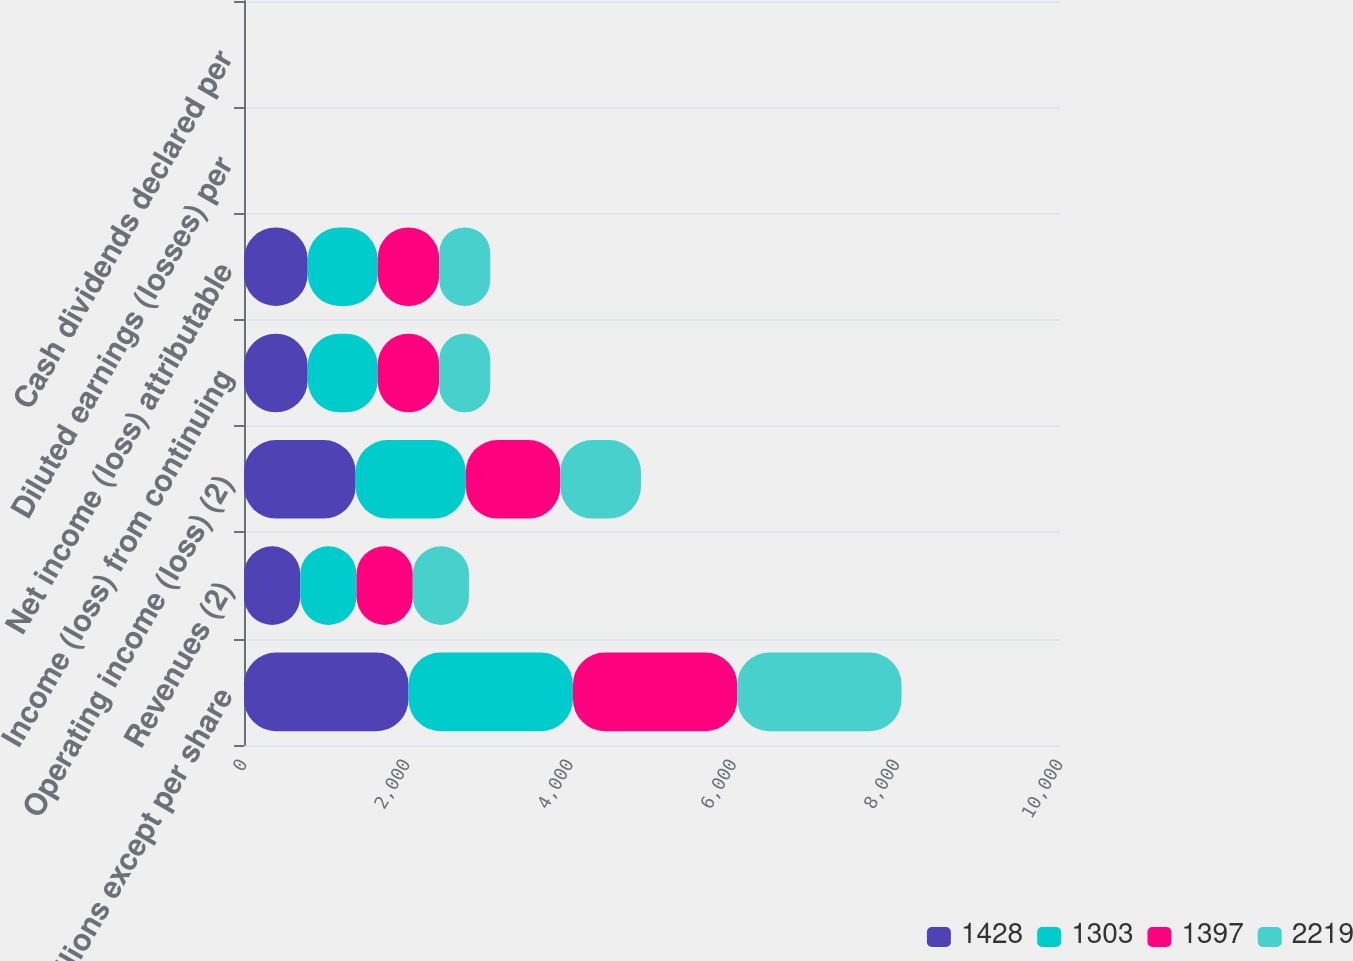<chart> <loc_0><loc_0><loc_500><loc_500><stacked_bar_chart><ecel><fcel>( in millions except per share<fcel>Revenues (2)<fcel>Operating income (loss) (2)<fcel>Income (loss) from continuing<fcel>Net income (loss) attributable<fcel>Diluted earnings (losses) per<fcel>Cash dividends declared per<nl><fcel>1428<fcel>2016<fcel>689.5<fcel>1368<fcel>780<fcel>780<fcel>2.64<fcel>1.15<nl><fcel>1303<fcel>2015<fcel>689.5<fcel>1350<fcel>859<fcel>859<fcel>3.15<fcel>0.95<nl><fcel>1397<fcel>2014<fcel>689.5<fcel>1159<fcel>753<fcel>753<fcel>2.54<fcel>0.77<nl><fcel>2219<fcel>2013<fcel>689.5<fcel>988<fcel>626<fcel>626<fcel>2<fcel>0.64<nl></chart> 